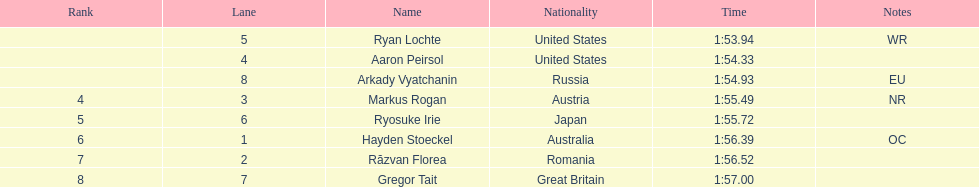How many swimmers were from the us? 2. 